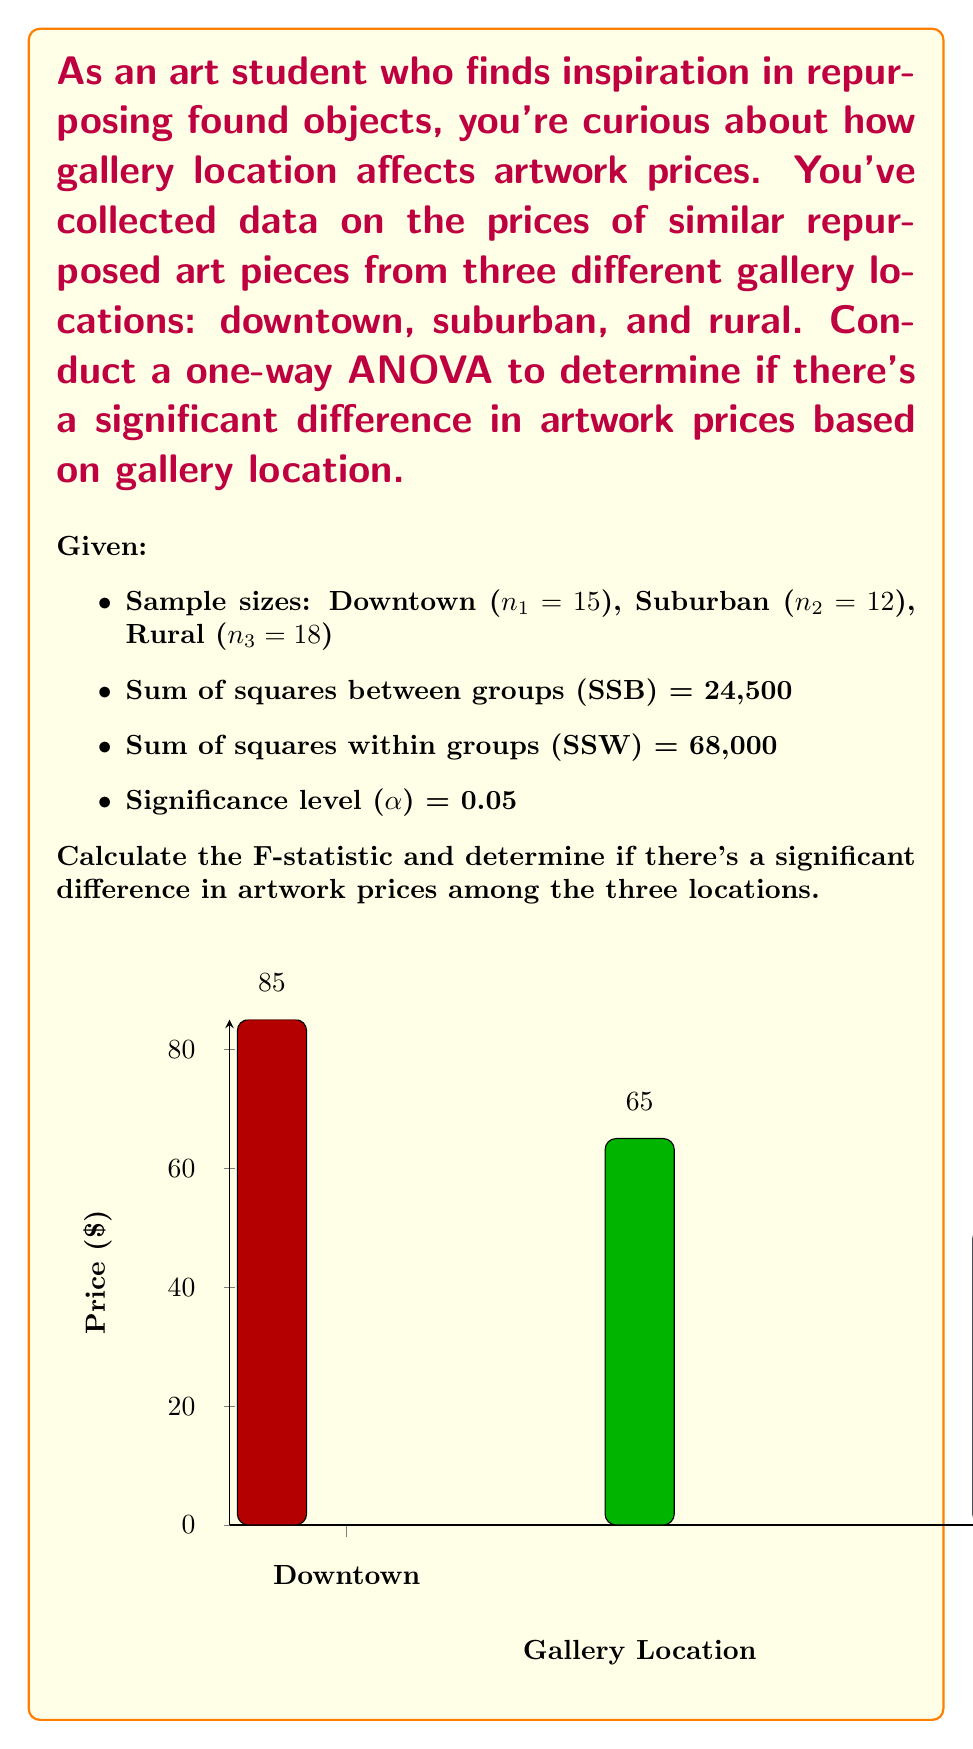Give your solution to this math problem. Let's solve this step-by-step:

1) First, calculate the degrees of freedom:
   - df between groups (df₁) = number of groups - 1 = 3 - 1 = 2
   - df within groups (df₂) = total sample size - number of groups
     = (15 + 12 + 18) - 3 = 42

2) Calculate mean square between groups (MSB) and mean square within groups (MSW):
   $$MSB = \frac{SSB}{df_1} = \frac{24,500}{2} = 12,250$$
   $$MSW = \frac{SSW}{df_2} = \frac{68,000}{42} \approx 1,619.05$$

3) Calculate the F-statistic:
   $$F = \frac{MSB}{MSW} = \frac{12,250}{1,619.05} \approx 7.57$$

4) Find the critical F-value:
   For α = 0.05, df₁ = 2, and df₂ = 42, the critical F-value is approximately 3.22 (from F-distribution table).

5) Compare the calculated F-statistic to the critical F-value:
   7.57 > 3.22, so we reject the null hypothesis.

6) Interpretation: There is a significant difference in artwork prices among the three gallery locations at the 0.05 significance level.
Answer: F(2,42) = 7.57, p < 0.05; significant difference exists 